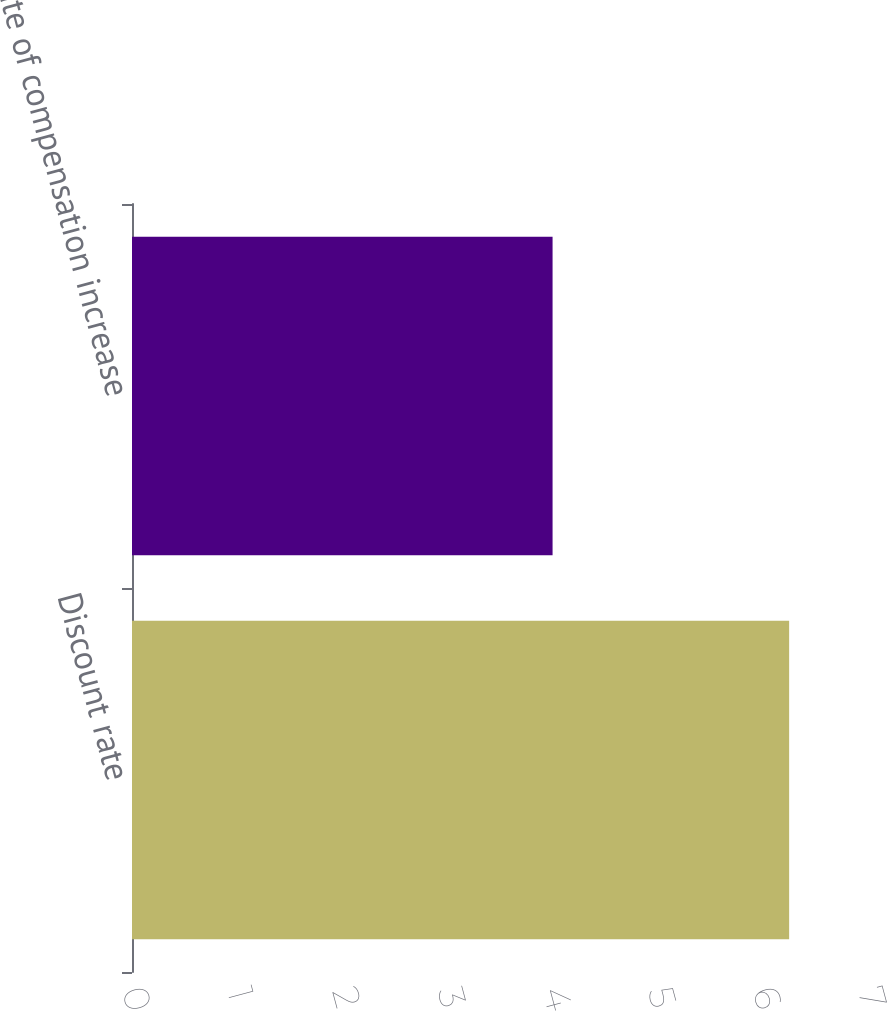Convert chart to OTSL. <chart><loc_0><loc_0><loc_500><loc_500><bar_chart><fcel>Discount rate<fcel>rate of compensation increase<nl><fcel>6.25<fcel>4<nl></chart> 